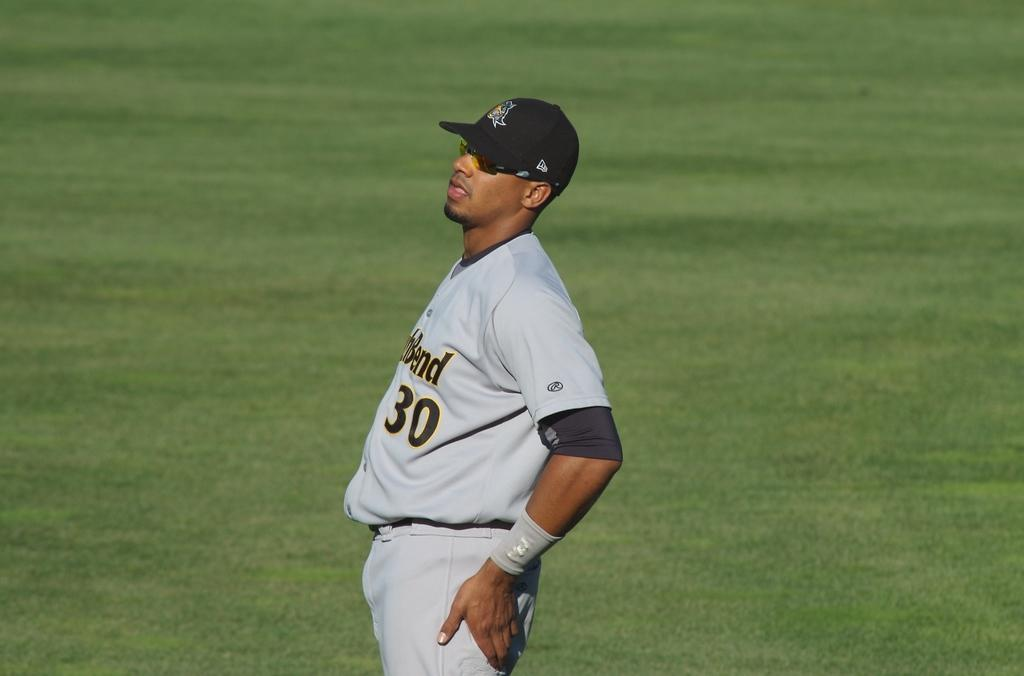<image>
Relay a brief, clear account of the picture shown. A man in a baseball uniform with the word Bend on the front. 